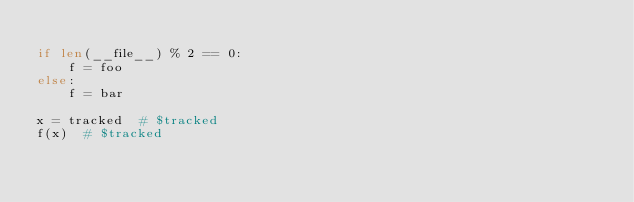Convert code to text. <code><loc_0><loc_0><loc_500><loc_500><_Python_>
if len(__file__) % 2 == 0:
    f = foo
else:
    f = bar

x = tracked  # $tracked
f(x)  # $tracked
</code> 